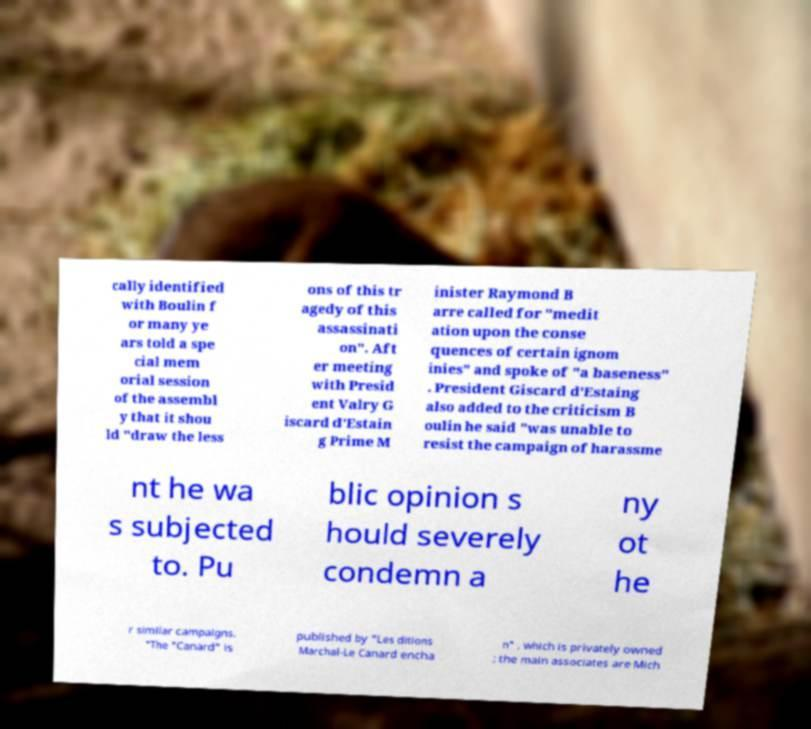Could you extract and type out the text from this image? cally identified with Boulin f or many ye ars told a spe cial mem orial session of the assembl y that it shou ld "draw the less ons of this tr agedy of this assassinati on". Aft er meeting with Presid ent Valry G iscard d'Estain g Prime M inister Raymond B arre called for "medit ation upon the conse quences of certain ignom inies" and spoke of "a baseness" . President Giscard d'Estaing also added to the criticism B oulin he said "was unable to resist the campaign of harassme nt he wa s subjected to. Pu blic opinion s hould severely condemn a ny ot he r similar campaigns. "The "Canard" is published by "Les ditions Marchal-Le Canard encha n" , which is privately owned ; the main associates are Mich 